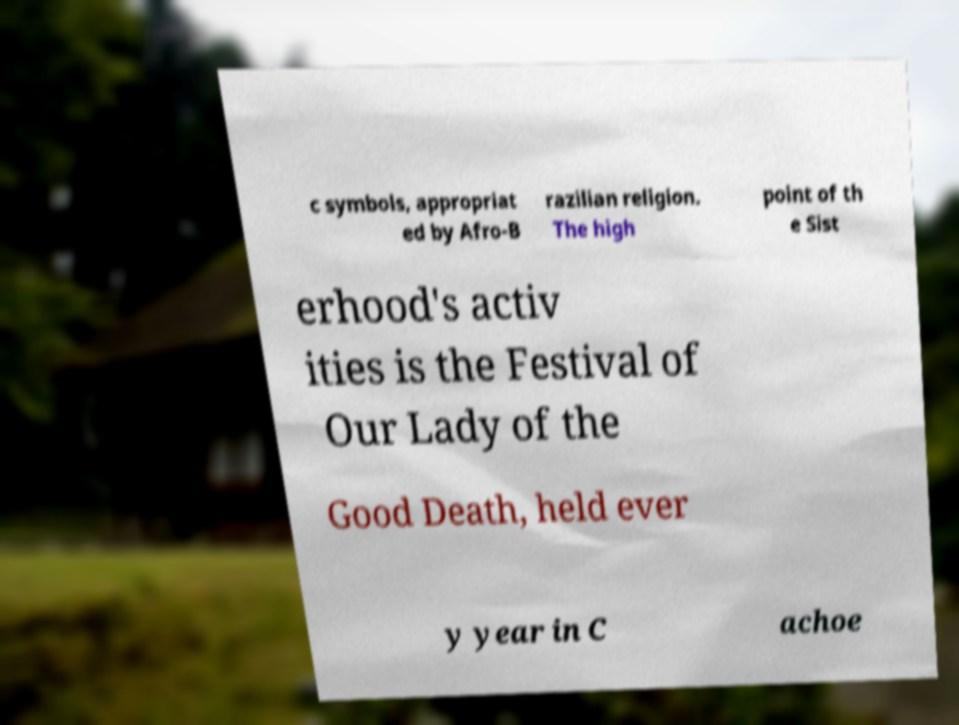Please identify and transcribe the text found in this image. c symbols, appropriat ed by Afro-B razilian religion. The high point of th e Sist erhood's activ ities is the Festival of Our Lady of the Good Death, held ever y year in C achoe 